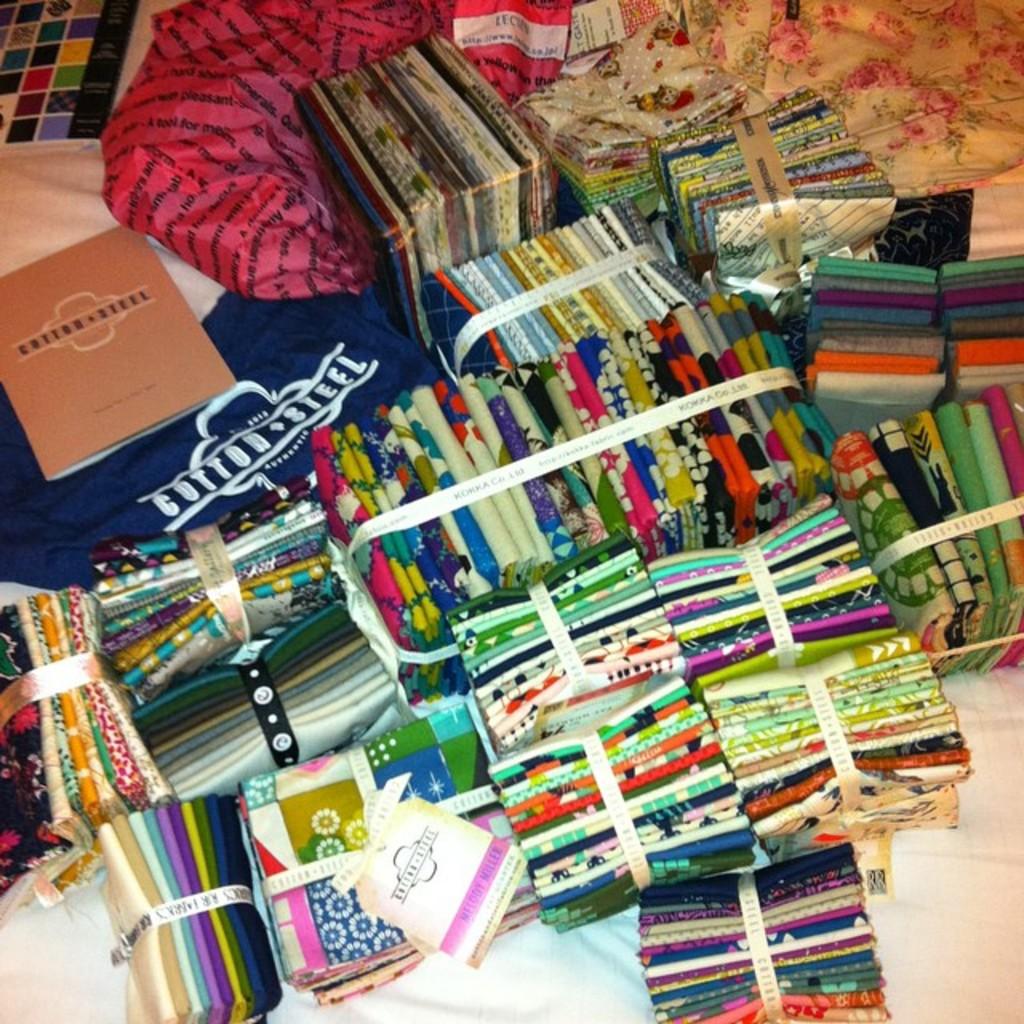What brand is this fabric?
Your answer should be very brief. Cotton steel. 